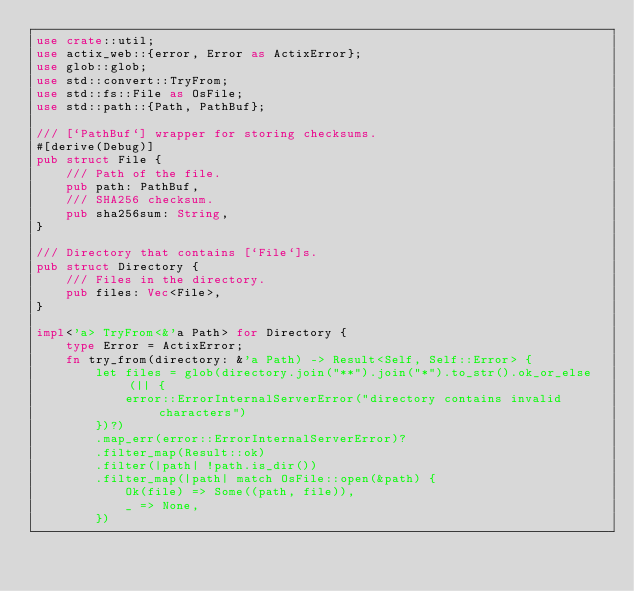<code> <loc_0><loc_0><loc_500><loc_500><_Rust_>use crate::util;
use actix_web::{error, Error as ActixError};
use glob::glob;
use std::convert::TryFrom;
use std::fs::File as OsFile;
use std::path::{Path, PathBuf};

/// [`PathBuf`] wrapper for storing checksums.
#[derive(Debug)]
pub struct File {
    /// Path of the file.
    pub path: PathBuf,
    /// SHA256 checksum.
    pub sha256sum: String,
}

/// Directory that contains [`File`]s.
pub struct Directory {
    /// Files in the directory.
    pub files: Vec<File>,
}

impl<'a> TryFrom<&'a Path> for Directory {
    type Error = ActixError;
    fn try_from(directory: &'a Path) -> Result<Self, Self::Error> {
        let files = glob(directory.join("**").join("*").to_str().ok_or_else(|| {
            error::ErrorInternalServerError("directory contains invalid characters")
        })?)
        .map_err(error::ErrorInternalServerError)?
        .filter_map(Result::ok)
        .filter(|path| !path.is_dir())
        .filter_map(|path| match OsFile::open(&path) {
            Ok(file) => Some((path, file)),
            _ => None,
        })</code> 